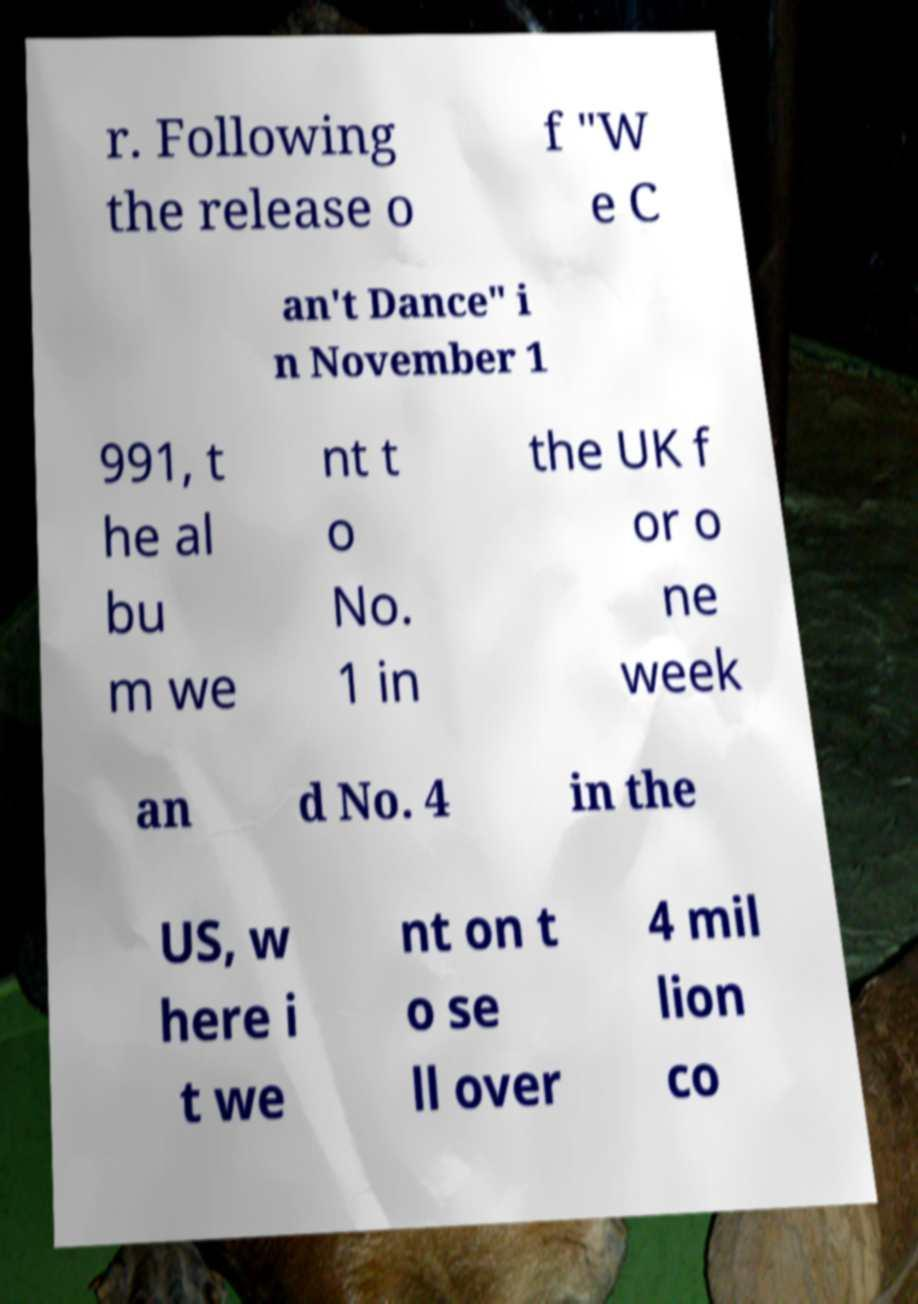What messages or text are displayed in this image? I need them in a readable, typed format. r. Following the release o f "W e C an't Dance" i n November 1 991, t he al bu m we nt t o No. 1 in the UK f or o ne week an d No. 4 in the US, w here i t we nt on t o se ll over 4 mil lion co 